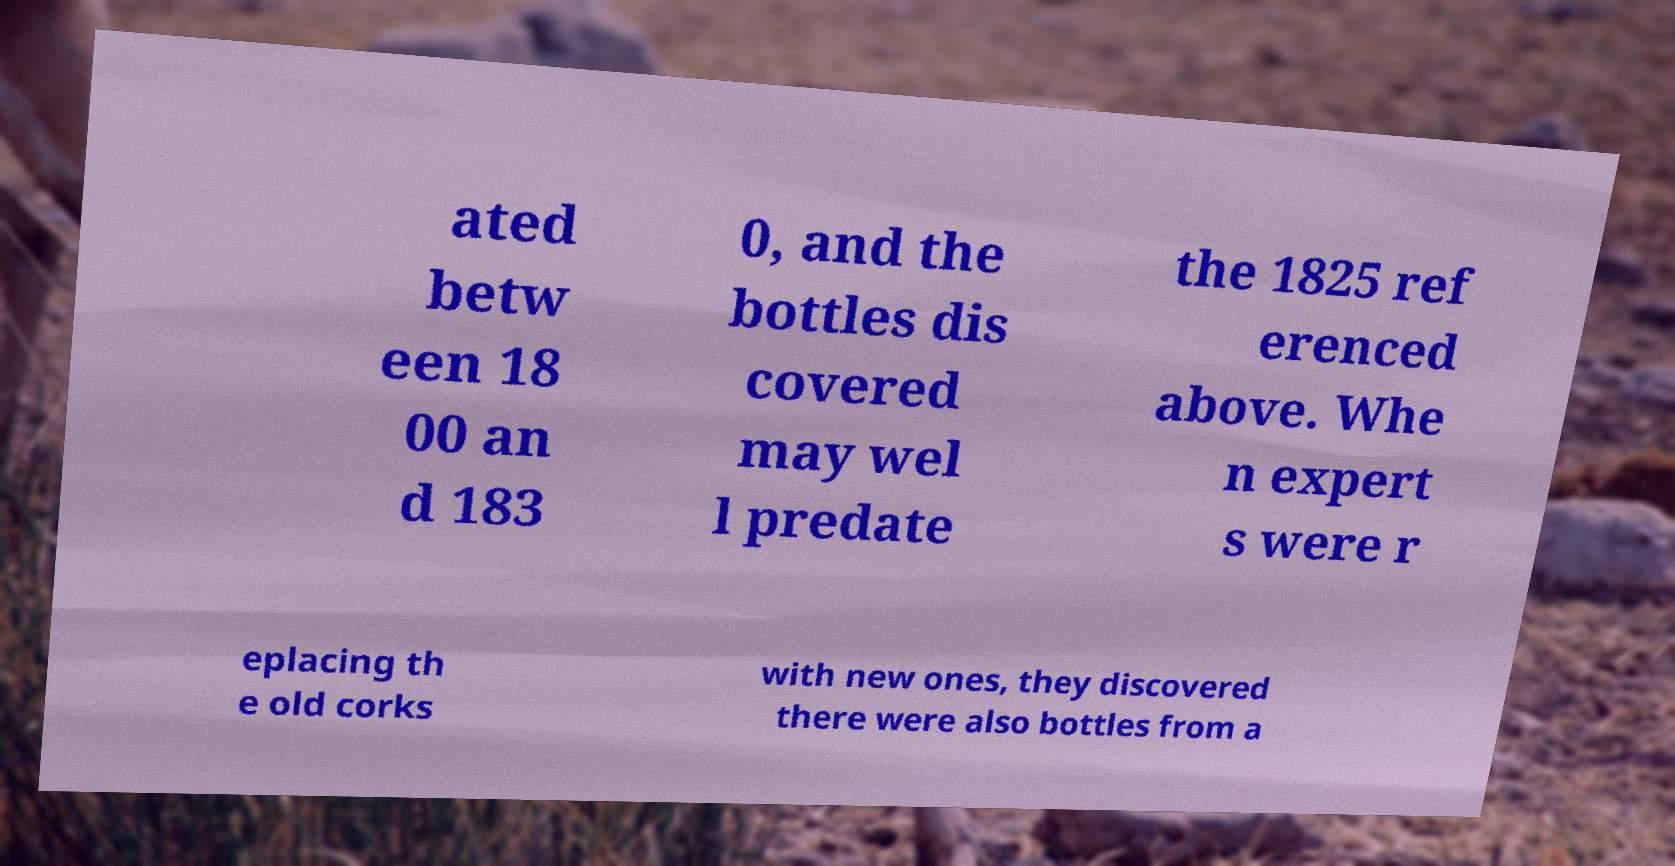Can you accurately transcribe the text from the provided image for me? ated betw een 18 00 an d 183 0, and the bottles dis covered may wel l predate the 1825 ref erenced above. Whe n expert s were r eplacing th e old corks with new ones, they discovered there were also bottles from a 